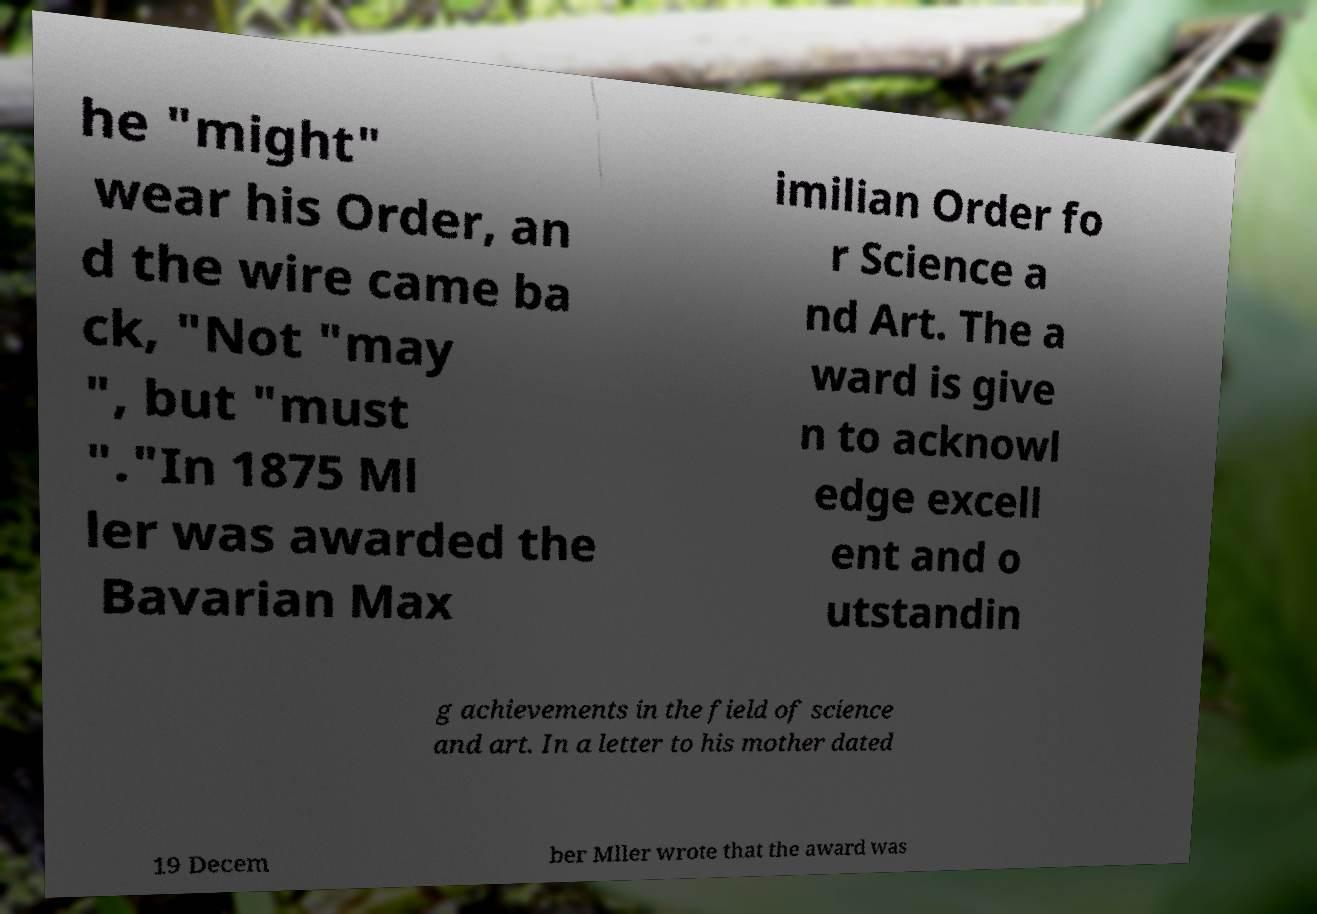I need the written content from this picture converted into text. Can you do that? he "might" wear his Order, an d the wire came ba ck, "Not "may ", but "must "."In 1875 Ml ler was awarded the Bavarian Max imilian Order fo r Science a nd Art. The a ward is give n to acknowl edge excell ent and o utstandin g achievements in the field of science and art. In a letter to his mother dated 19 Decem ber Mller wrote that the award was 